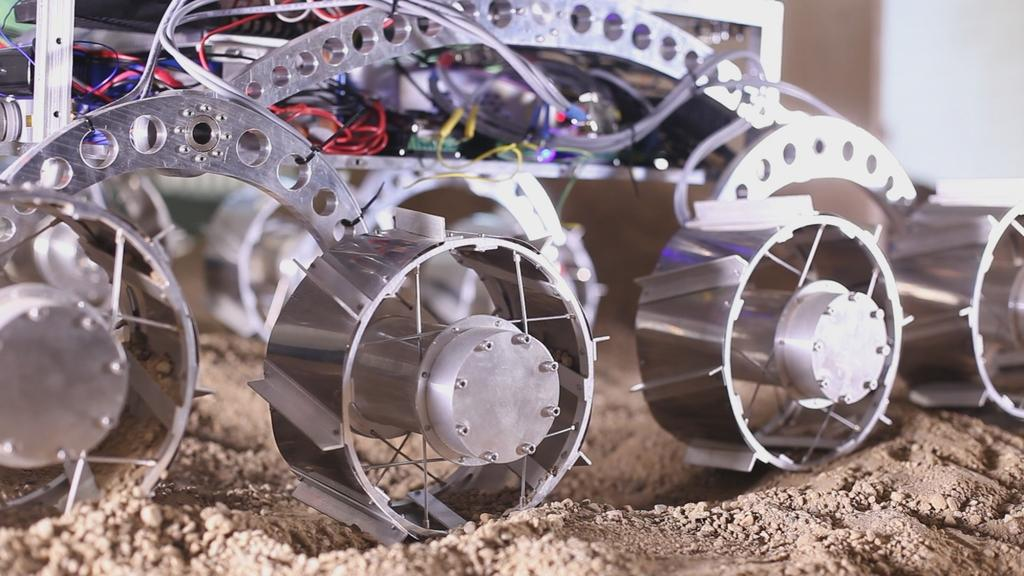What is the main subject in the foreground of the image? There is a remote car-like object on the ground in the foreground of the image. Can you describe the background of the image? The background of the image is blurry. What type of beam can be seen supporting the horse in the image? There is no beam or horse present in the image; it features a remote car-like object in the foreground and a blurry background. 